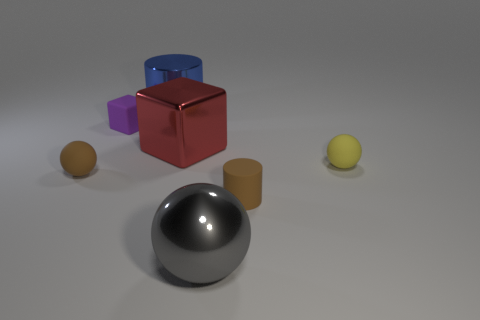Add 2 large green matte blocks. How many objects exist? 9 Subtract all tiny brown spheres. How many spheres are left? 2 Subtract all cylinders. How many objects are left? 5 Add 5 large metal cylinders. How many large metal cylinders are left? 6 Add 2 small gray cylinders. How many small gray cylinders exist? 2 Subtract 1 purple blocks. How many objects are left? 6 Subtract all big gray shiny objects. Subtract all matte things. How many objects are left? 2 